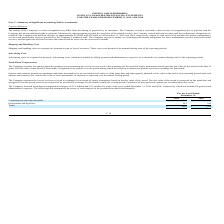According to Inpixon's financial document, How does the company account for options granted to employees? by measuring the cost of services received in exchange for the award of equity instruments based upon the fair value of the award on the date of grant.. The document states: "Company accounts for options granted to employees by measuring the cost of services received in exchange for the award of equity instruments based upo..." Also, How are options and warrants granted to consultants and other non-employees recorded? at fair value as of the grant date and subsequently adjusted to fair value at the end of each reporting period until such options and warrants vest, and the fair value of such instruments, as adjusted, is expensed over the related vesting period.. The document states: "o consultants and other non-employees are recorded at fair value as of the grant date and subsequently adjusted to fair value at the end of each repor..." Also, What was the Compensation and related benefits in 2019 and 2018 respectively? The document shows two values: $3,247 and $949 (in thousands). From the document: "Compensation and related benefits $ 3,247 $ 949 Compensation and related benefits $ 3,247 $ 949..." Additionally, In which year was Professional and legal fees less than 500 thousands? According to the financial document, 2019. The relevant text states: "NCIAL STATEMENTS FOR THE YEARS ENDED DECEMBER 31, 2019 AND 2018..." Also, can you calculate: What is the change in the Compensation and related benefits from 2018 to 2019? Based on the calculation: 3,247 - 949, the result is 2298 (in thousands). This is based on the information: "Compensation and related benefits $ 3,247 $ 949 Compensation and related benefits $ 3,247 $ 949..." The key data points involved are: 3,247, 949. Also, can you calculate: What was the average Professional and legal fees for 2018 and 2019? To answer this question, I need to perform calculations using the financial data. The calculation is: (242 + 545) / 2, which equals 393.5 (in thousands). This is based on the information: "Professional and legal fees 242 545 Professional and legal fees 242 545..." The key data points involved are: 242, 545. 